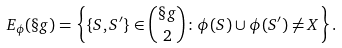Convert formula to latex. <formula><loc_0><loc_0><loc_500><loc_500>E _ { \phi } ( \S g ) = \left \{ \{ S , S ^ { \prime } \} \in \binom { \S g } { 2 } \colon \phi ( S ) \cup \phi ( S ^ { \prime } ) \neq X \right \} .</formula> 